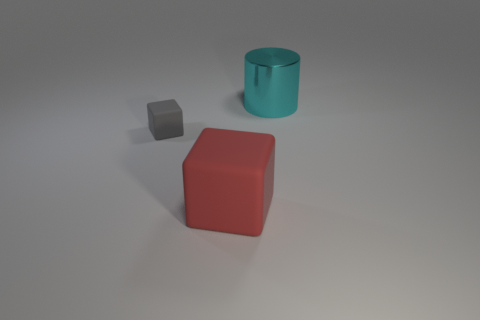The thing that is on the right side of the gray matte block and in front of the metal cylinder is made of what material?
Give a very brief answer. Rubber. What color is the large cylinder?
Your answer should be compact. Cyan. What number of other things are there of the same shape as the shiny thing?
Provide a short and direct response. 0. Is the number of gray rubber things that are in front of the tiny gray thing the same as the number of cyan things that are in front of the red cube?
Ensure brevity in your answer.  Yes. What is the material of the tiny cube?
Your response must be concise. Rubber. What is the big object on the left side of the big cyan cylinder made of?
Provide a short and direct response. Rubber. Is there any other thing that has the same material as the large cylinder?
Provide a short and direct response. No. Are there more small rubber blocks that are right of the large rubber thing than tiny purple objects?
Make the answer very short. No. Is there a tiny object behind the rubber thing that is behind the matte cube that is in front of the gray rubber object?
Make the answer very short. No. Are there any large rubber things behind the red thing?
Ensure brevity in your answer.  No. 